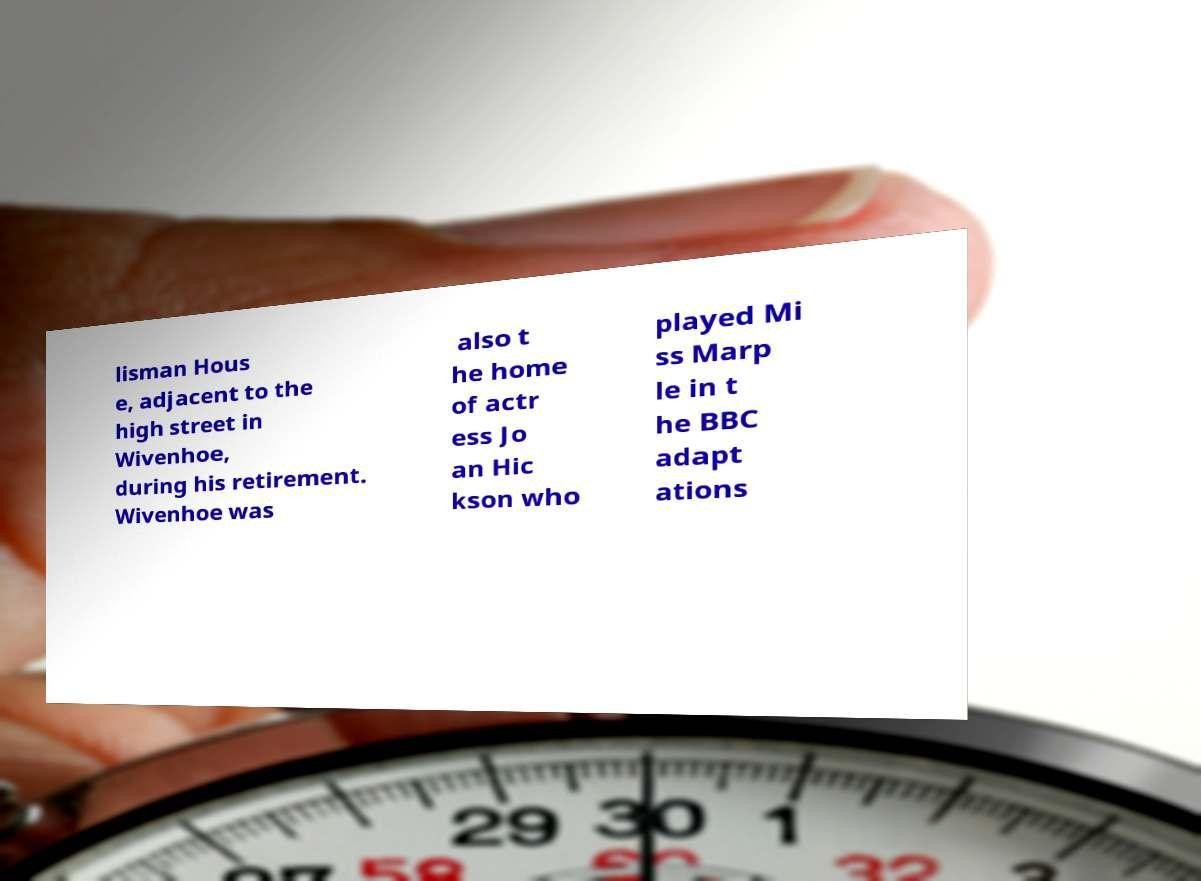I need the written content from this picture converted into text. Can you do that? lisman Hous e, adjacent to the high street in Wivenhoe, during his retirement. Wivenhoe was also t he home of actr ess Jo an Hic kson who played Mi ss Marp le in t he BBC adapt ations 